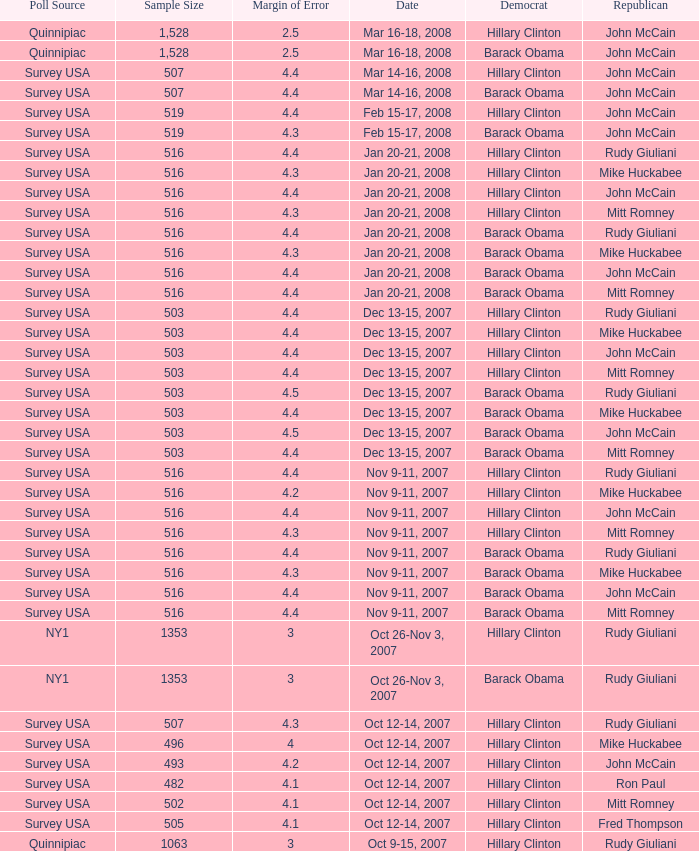Which democrat was chosen in the poll with a sample size under 516 where the republican picked was ron paul? Hillary Clinton. 